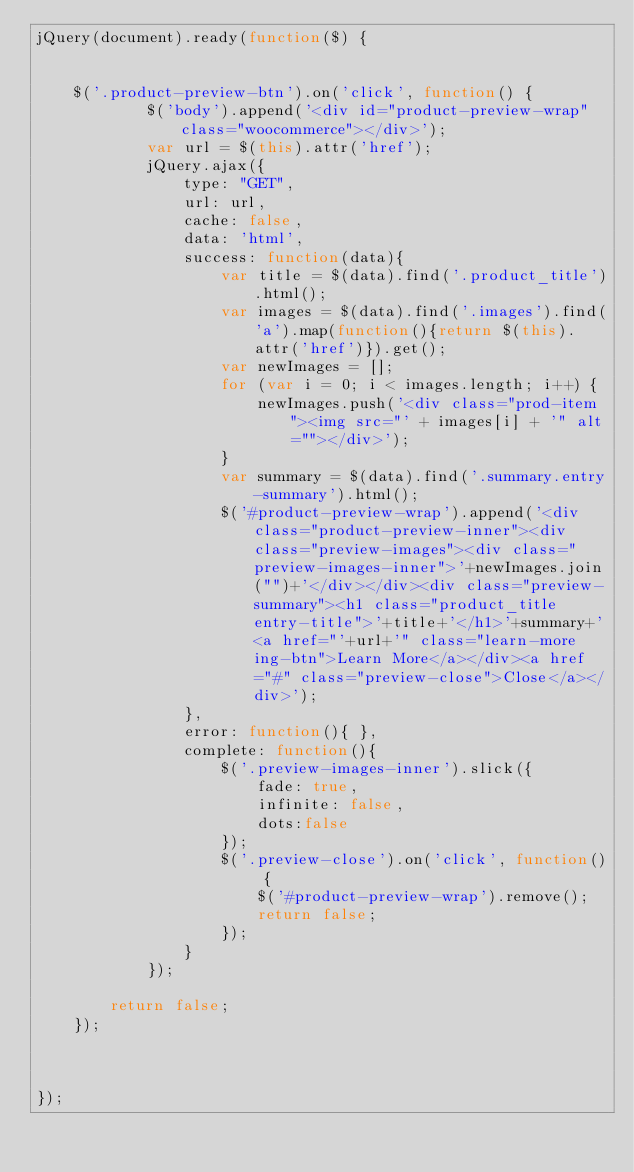Convert code to text. <code><loc_0><loc_0><loc_500><loc_500><_JavaScript_>jQuery(document).ready(function($) {


	$('.product-preview-btn').on('click', function() {
			$('body').append('<div id="product-preview-wrap" class="woocommerce"></div>');
			var url = $(this).attr('href');
			jQuery.ajax({
				type: "GET",
				url: url,
				cache: false,
				data: 'html',
				success: function(data){
					var title = $(data).find('.product_title').html();
					var images = $(data).find('.images').find('a').map(function(){return $(this).attr('href')}).get();
					var newImages = [];
					for (var i = 0; i < images.length; i++) {
					    newImages.push('<div class="prod-item"><img src="' + images[i] + '" alt=""></div>');
					}
					var summary = $(data).find('.summary.entry-summary').html();
					$('#product-preview-wrap').append('<div class="product-preview-inner"><div class="preview-images"><div class="preview-images-inner">'+newImages.join("")+'</div></div><div class="preview-summary"><h1 class="product_title entry-title">'+title+'</h1>'+summary+'<a href="'+url+'" class="learn-more ing-btn">Learn More</a></div><a href="#" class="preview-close">Close</a></div>');
				},
				error: function(){ },
				complete: function(){
					$('.preview-images-inner').slick({
						fade: true,
						infinite: false,
						dots:false
					});
					$('.preview-close').on('click', function() {
						$('#product-preview-wrap').remove();
						return false;
					});
				}
			});

		return false;
	});



});</code> 